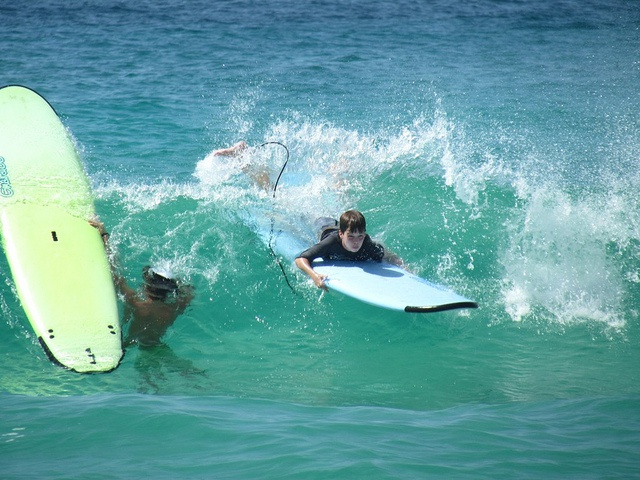Describe the objects in this image and their specific colors. I can see surfboard in blue, lightyellow, lightgreen, and turquoise tones, surfboard in blue, lightblue, teal, and black tones, people in blue, black, darkgreen, and teal tones, and people in blue, black, gray, and darkgray tones in this image. 